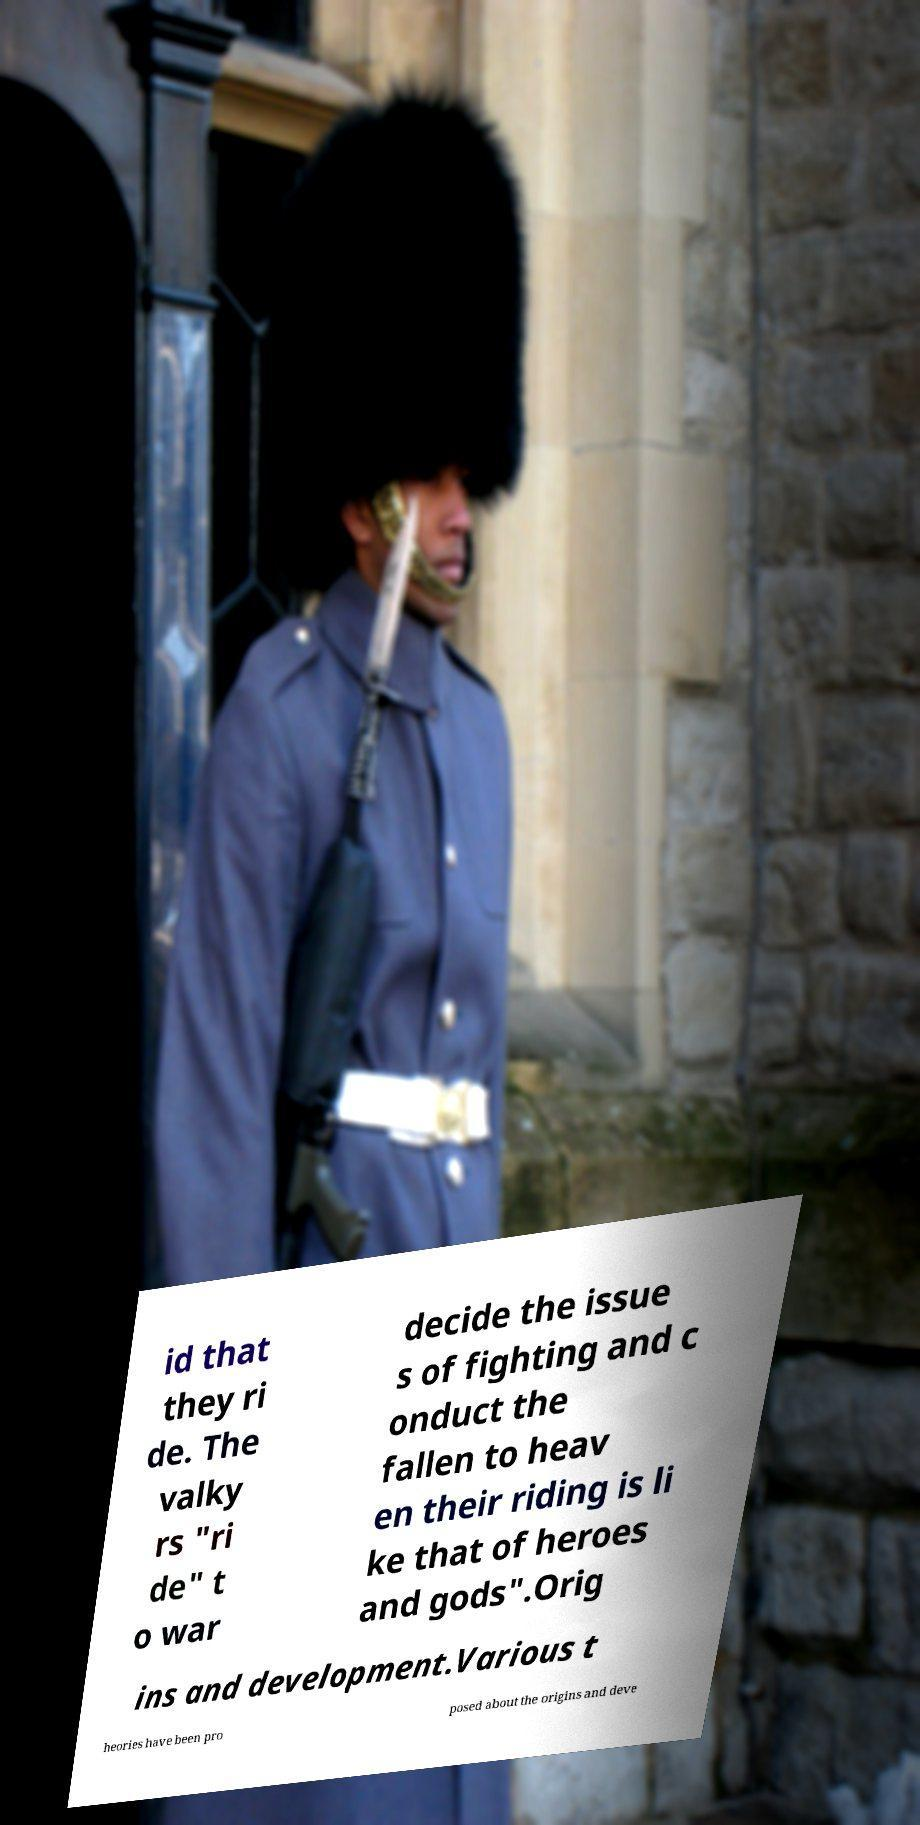I need the written content from this picture converted into text. Can you do that? id that they ri de. The valky rs "ri de" t o war decide the issue s of fighting and c onduct the fallen to heav en their riding is li ke that of heroes and gods".Orig ins and development.Various t heories have been pro posed about the origins and deve 